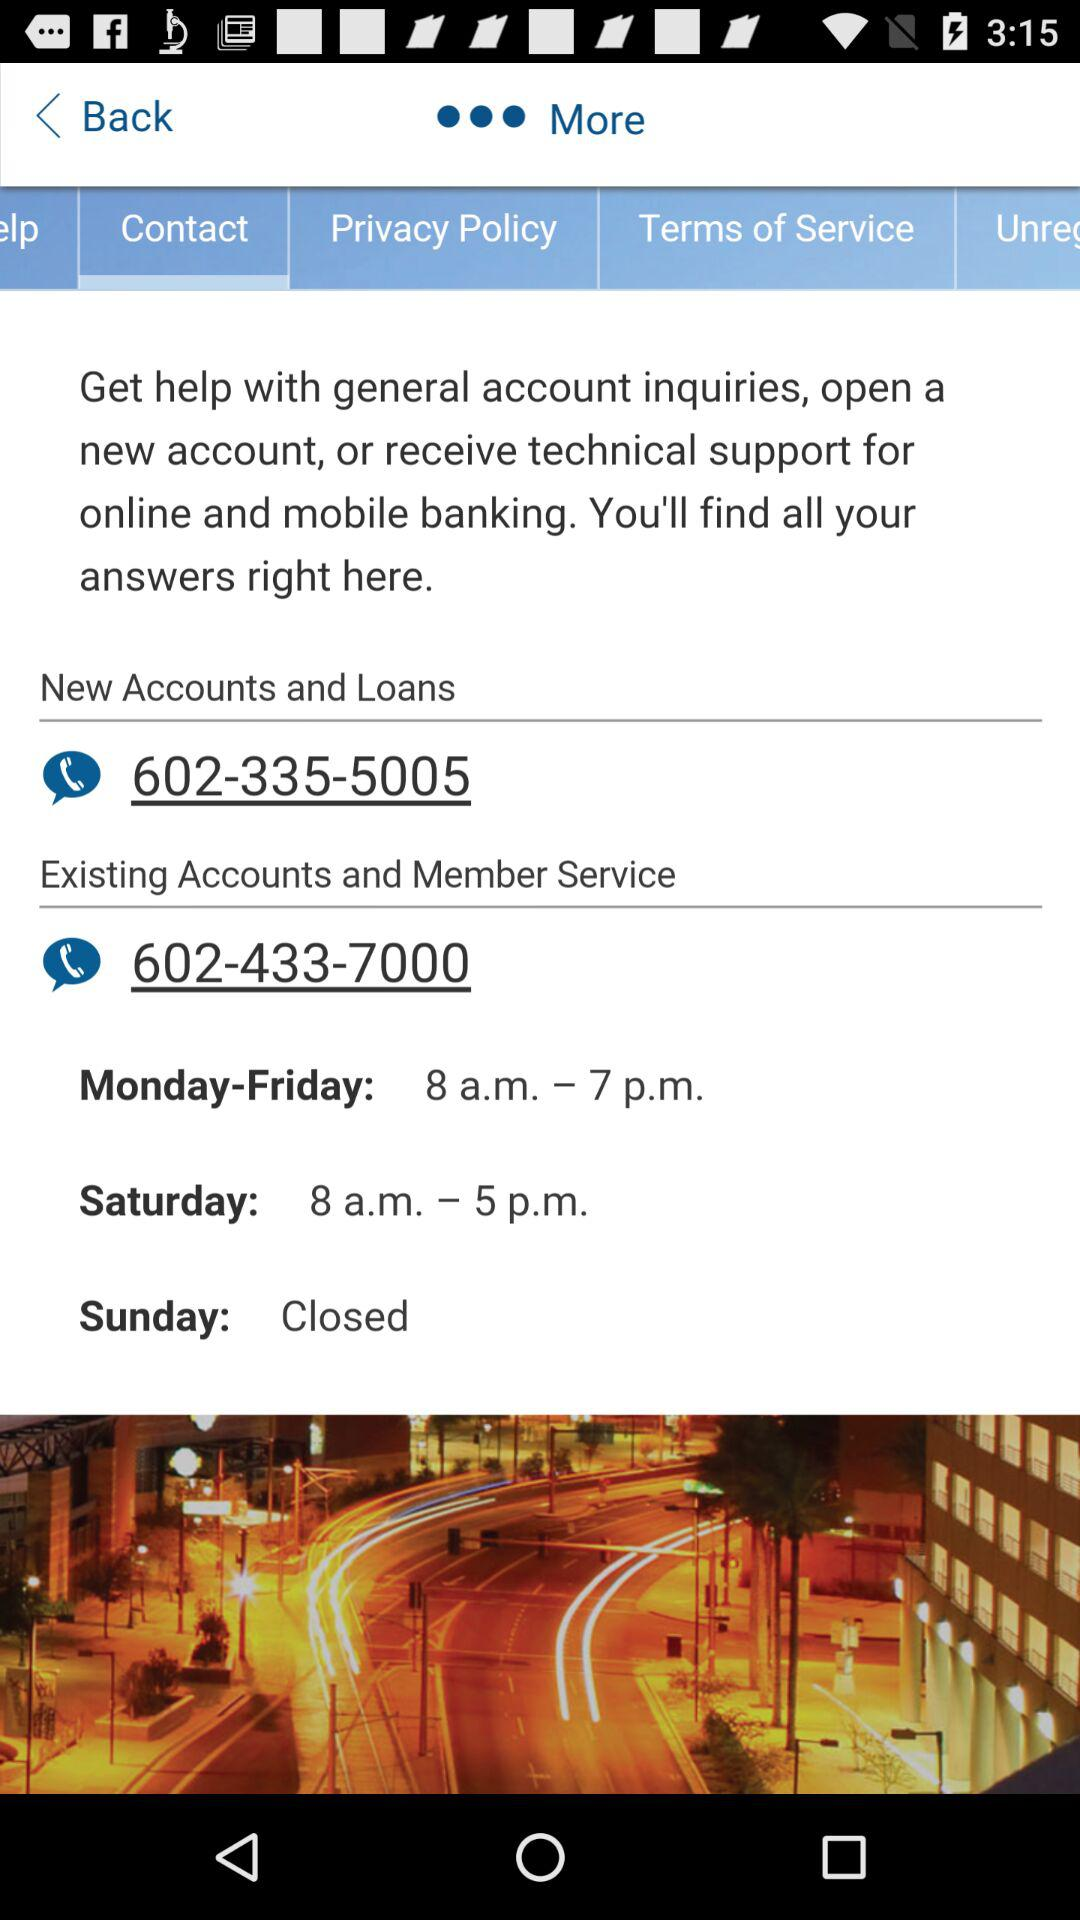What's the contact number for new accounts and loans? The contact number for new accounts and loans is 602-335-5005. 